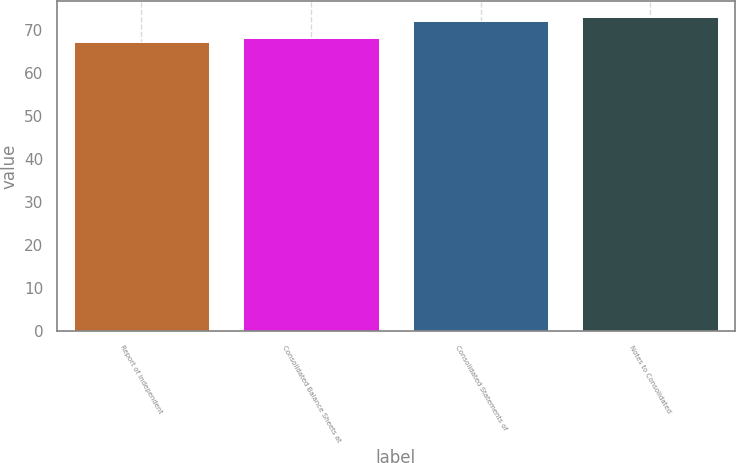Convert chart. <chart><loc_0><loc_0><loc_500><loc_500><bar_chart><fcel>Report of Independent<fcel>Consolidated Balance Sheets at<fcel>Consolidated Statements of<fcel>Notes to Consolidated<nl><fcel>67<fcel>68<fcel>72<fcel>73<nl></chart> 